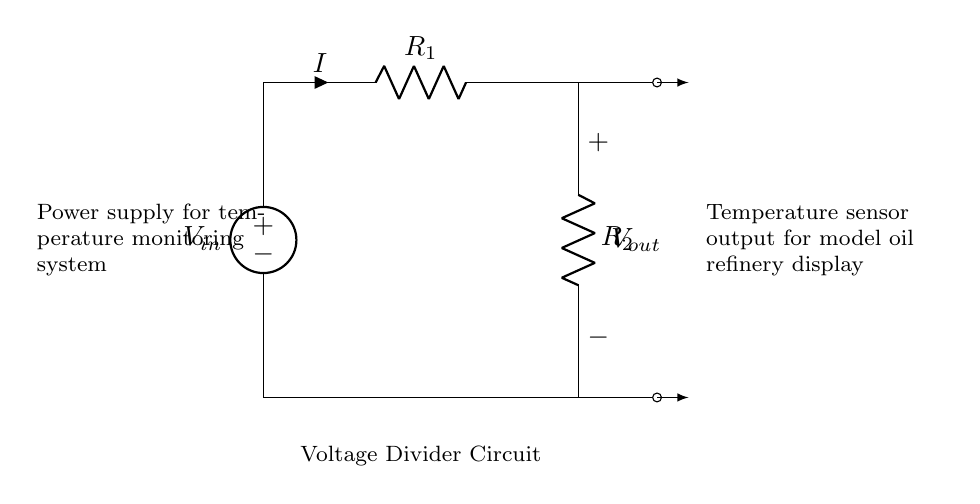What is the input voltage labeled as in the circuit? The input voltage is labeled as V_in in the circuit, indicating the voltage supplied to the voltage divider.
Answer: V_in What are the values of the resistors in the voltage divider? The circuit diagram indicates two resistors: R_1 and R_2. The specific values are not visible from the diagram, but they are essential to calculate the output voltage.
Answer: R_1, R_2 What does V_out represent in this circuit? V_out represents the output voltage from the voltage divider, which is derived from the ratio of the two resistors in the circuit and affects the temperature sensor output.
Answer: Output voltage Is there a current flowing through the circuit, and what is its designation? Yes, there is a current flowing through the circuit, and it is designated as I. This current flows from the input voltage through R_1 and R_2 in series.
Answer: I How does the output voltage relate to the input voltage in a voltage divider? The output voltage can be calculated using the formula: V_out = (R_2 / (R_1 + R_2)) * V_in. This shows that V_out is a fraction of V_in based on the resistor values.
Answer: V_out = (R_2 / (R_1 + R_2)) * V_in What is the purpose of the temperature sensor in the model oil refinery circuit? The purpose of the temperature sensor is to monitor the temperature based on the voltage output from the voltage divider, allowing the system to provide relevant data for operations in the oil refinery.
Answer: Temperature monitoring Where is the power supply located in the circuit? The power supply is indicated on the left side of the circuit, providing the necessary voltage input for the entire temperature monitoring system.
Answer: Left side 